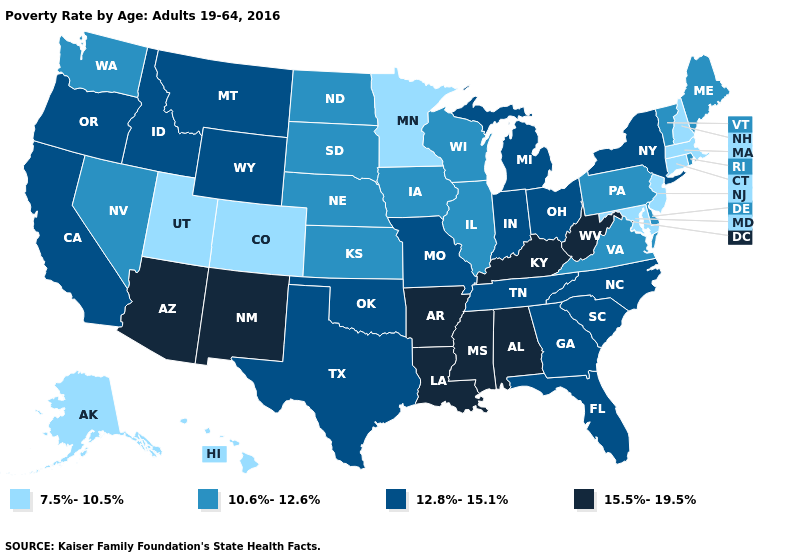Among the states that border Minnesota , which have the highest value?
Give a very brief answer. Iowa, North Dakota, South Dakota, Wisconsin. Does Oregon have the highest value in the West?
Keep it brief. No. Does Mississippi have the highest value in the USA?
Be succinct. Yes. Does the first symbol in the legend represent the smallest category?
Be succinct. Yes. What is the value of New Hampshire?
Keep it brief. 7.5%-10.5%. Does Georgia have a higher value than Virginia?
Answer briefly. Yes. What is the value of New Jersey?
Give a very brief answer. 7.5%-10.5%. Does Indiana have the highest value in the MidWest?
Keep it brief. Yes. What is the value of Oregon?
Answer briefly. 12.8%-15.1%. Does Delaware have the same value as Maine?
Keep it brief. Yes. What is the value of New York?
Quick response, please. 12.8%-15.1%. What is the highest value in states that border South Carolina?
Be succinct. 12.8%-15.1%. Name the states that have a value in the range 12.8%-15.1%?
Give a very brief answer. California, Florida, Georgia, Idaho, Indiana, Michigan, Missouri, Montana, New York, North Carolina, Ohio, Oklahoma, Oregon, South Carolina, Tennessee, Texas, Wyoming. Does Idaho have a lower value than Arizona?
Concise answer only. Yes. What is the value of Oregon?
Short answer required. 12.8%-15.1%. 